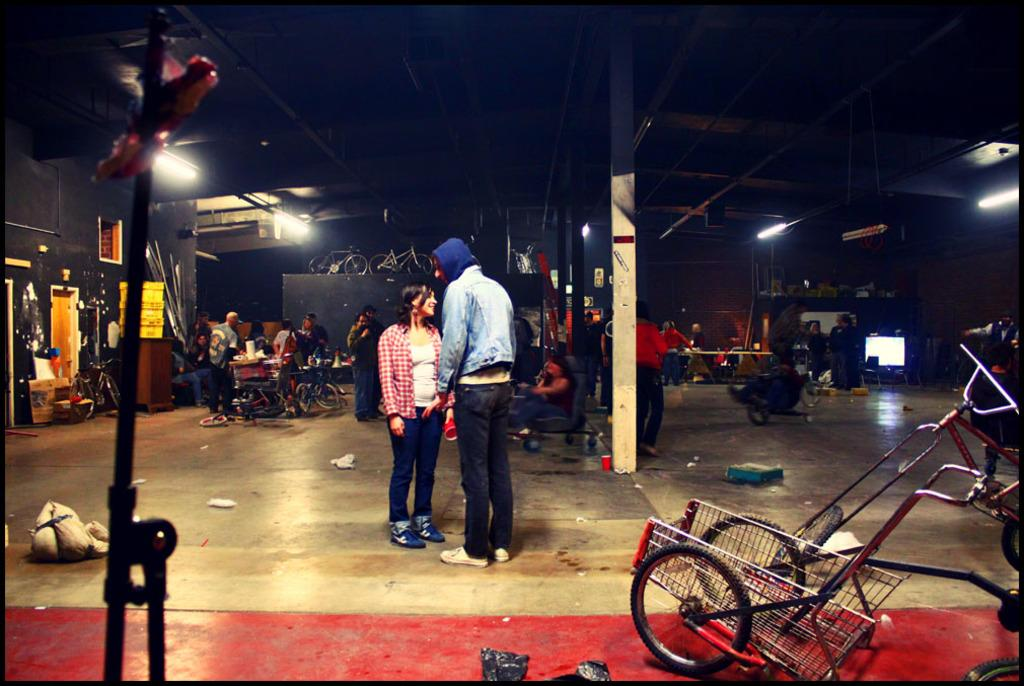What is the main subject in the foreground of the image? There is a vehicle in the foreground of the image. What can be seen behind the vehicle in the image? There are many people behind the vehicle in the image. What type of transportation is also visible in the image? There are cycles visible in the image. Can you describe any other objects present in the image? There are other objects present in the image, but their specific details are not mentioned in the provided facts. What song is being sung by the people behind the vehicle in the image? There is no information about any song being sung in the image, as the provided facts only mention the presence of people behind the vehicle. 